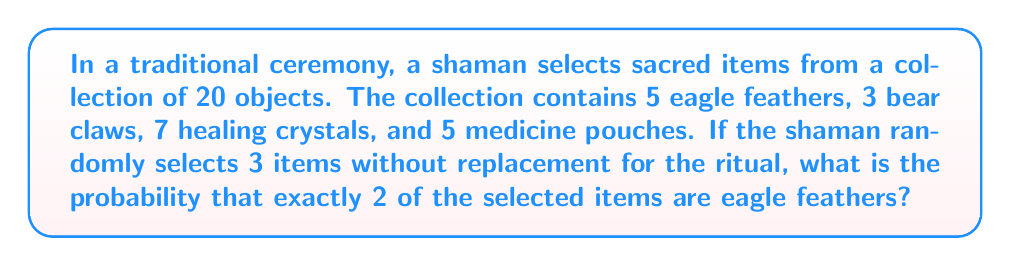Show me your answer to this math problem. To solve this problem, we'll use the concept of hypergeometric probability. We need to calculate the probability of selecting exactly 2 eagle feathers and 1 non-eagle feather item from the collection.

Step 1: Calculate the number of ways to select 2 eagle feathers from 5:
$$\binom{5}{2} = \frac{5!}{2!(5-2)!} = \frac{5 \cdot 4}{2 \cdot 1} = 10$$

Step 2: Calculate the number of ways to select 1 non-eagle feather item from the remaining 15 items:
$$\binom{15}{1} = 15$$

Step 3: Calculate the total number of ways to select 3 items from 20:
$$\binom{20}{3} = \frac{20!}{3!(20-3)!} = \frac{20 \cdot 19 \cdot 18}{3 \cdot 2 \cdot 1} = 1140$$

Step 4: Apply the hypergeometric probability formula:

$$P(\text{2 eagle feathers}) = \frac{\binom{5}{2} \cdot \binom{15}{1}}{\binom{20}{3}} = \frac{10 \cdot 15}{1140} = \frac{150}{1140} = \frac{25}{190}$$

Step 5: Simplify the fraction:
$$\frac{25}{190} = \frac{5}{38} \approx 0.1316$$

Therefore, the probability of selecting exactly 2 eagle feathers when randomly choosing 3 items is $\frac{5}{38}$ or approximately 0.1316 (13.16%).
Answer: $\frac{5}{38}$ or approximately 0.1316 (13.16%) 